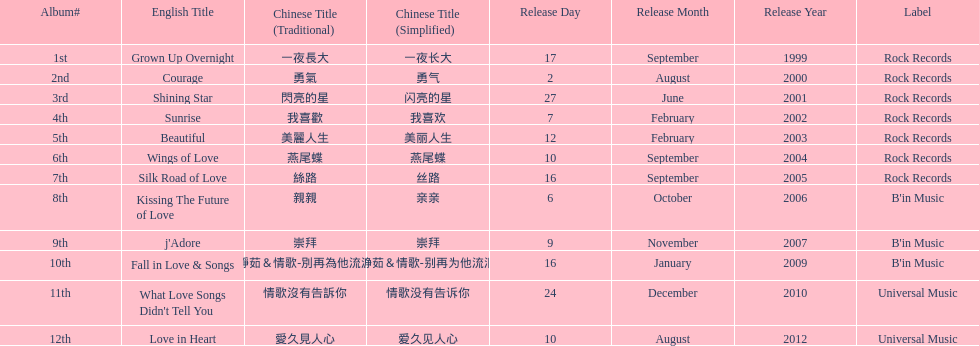Write the full table. {'header': ['Album#', 'English Title', 'Chinese Title (Traditional)', 'Chinese Title (Simplified)', 'Release Day', 'Release Month', 'Release Year', 'Label'], 'rows': [['1st', 'Grown Up Overnight', '一夜長大', '一夜长大', '17', 'September', '1999', 'Rock Records'], ['2nd', 'Courage', '勇氣', '勇气', '2', 'August', '2000', 'Rock Records'], ['3rd', 'Shining Star', '閃亮的星', '闪亮的星', '27', 'June', '2001', 'Rock Records'], ['4th', 'Sunrise', '我喜歡', '我喜欢', '7', 'February', '2002', 'Rock Records'], ['5th', 'Beautiful', '美麗人生', '美丽人生', '12', 'February', '2003', 'Rock Records'], ['6th', 'Wings of Love', '燕尾蝶', '燕尾蝶', '10', 'September', '2004', 'Rock Records'], ['7th', 'Silk Road of Love', '絲路', '丝路', '16', 'September', '2005', 'Rock Records'], ['8th', 'Kissing The Future of Love', '親親', '亲亲', '6', 'October', '2006', "B'in Music"], ['9th', "j'Adore", '崇拜', '崇拜', '9', 'November', '2007', "B'in Music"], ['10th', 'Fall in Love & Songs', '靜茹＆情歌-別再為他流淚', '静茹＆情歌-别再为他流泪', '16', 'January', '2009', "B'in Music"], ['11th', "What Love Songs Didn't Tell You", '情歌沒有告訴你', '情歌没有告诉你', '24', 'December', '2010', 'Universal Music'], ['12th', 'Love in Heart', '愛久見人心', '爱久见人心', '10', 'August', '2012', 'Universal Music']]} What is the number of songs on rock records? 7. 